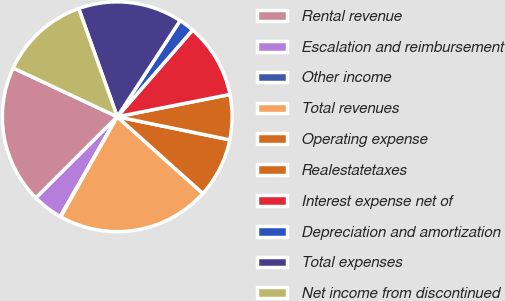Convert chart. <chart><loc_0><loc_0><loc_500><loc_500><pie_chart><fcel>Rental revenue<fcel>Escalation and reimbursement<fcel>Other income<fcel>Total revenues<fcel>Operating expense<fcel>Realestatetaxes<fcel>Interest expense net of<fcel>Depreciation and amortization<fcel>Total expenses<fcel>Net income from discontinued<nl><fcel>19.46%<fcel>4.25%<fcel>0.09%<fcel>21.54%<fcel>8.41%<fcel>6.33%<fcel>10.5%<fcel>2.17%<fcel>14.66%<fcel>12.58%<nl></chart> 